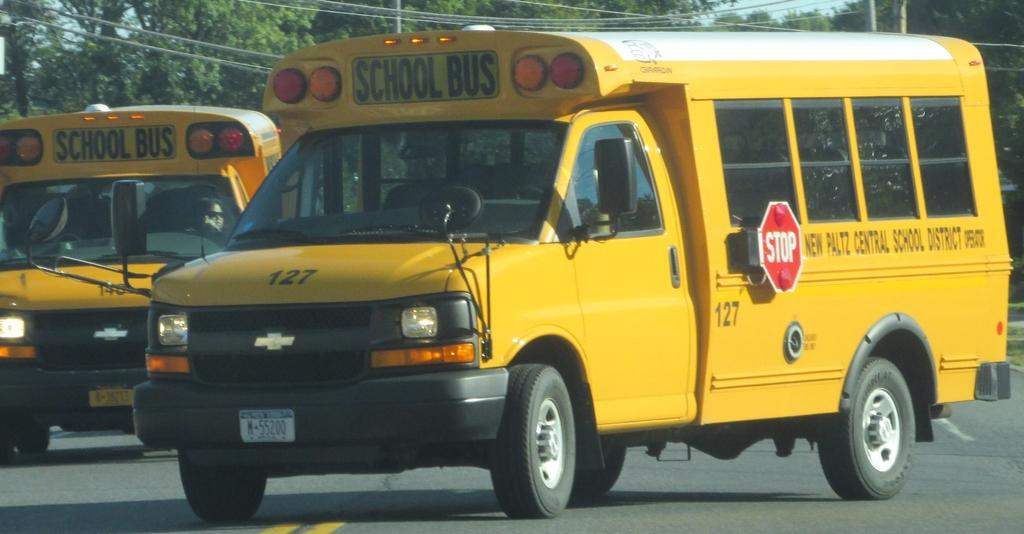<image>
Relay a brief, clear account of the picture shown. A yellow school bus with the number 127 on the side. 